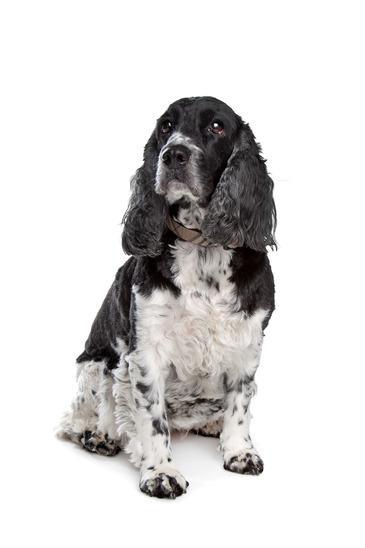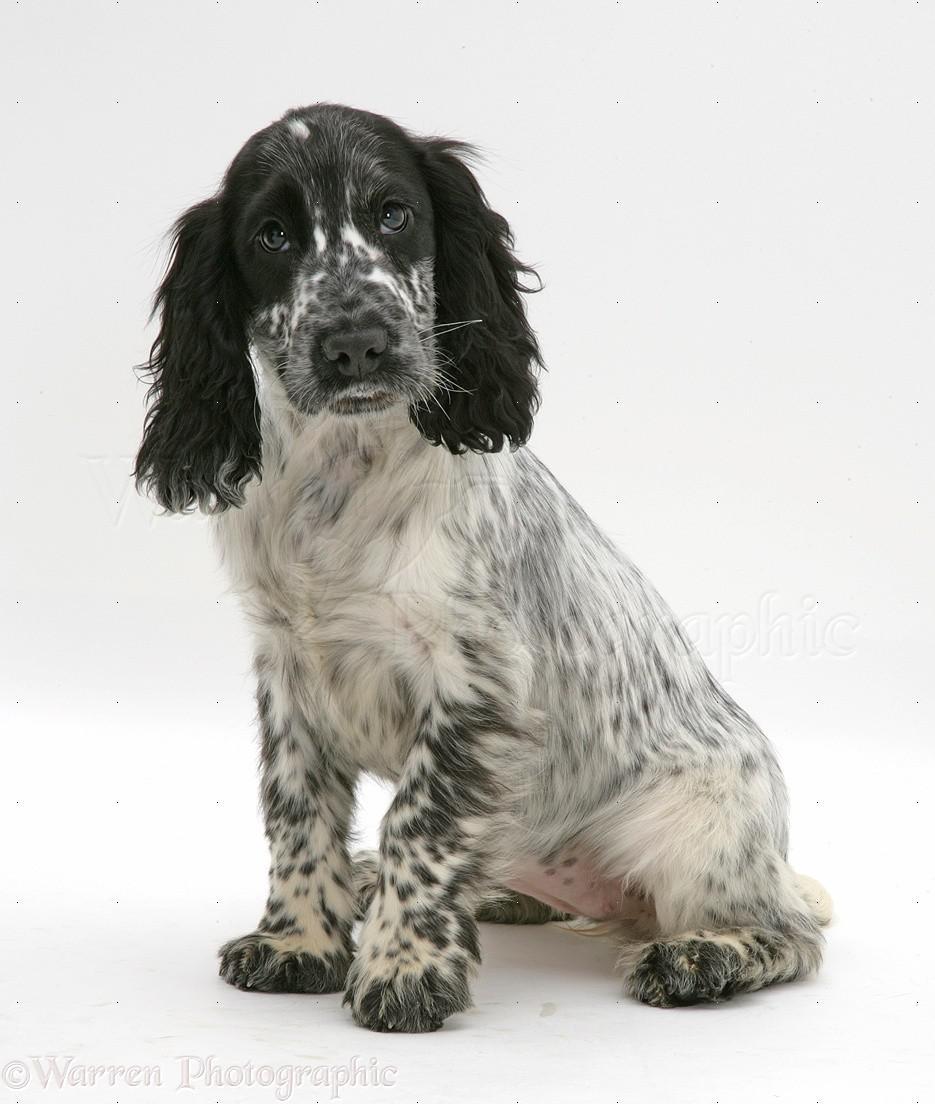The first image is the image on the left, the second image is the image on the right. Assess this claim about the two images: "One dog is not in a sitting position.". Correct or not? Answer yes or no. No. 